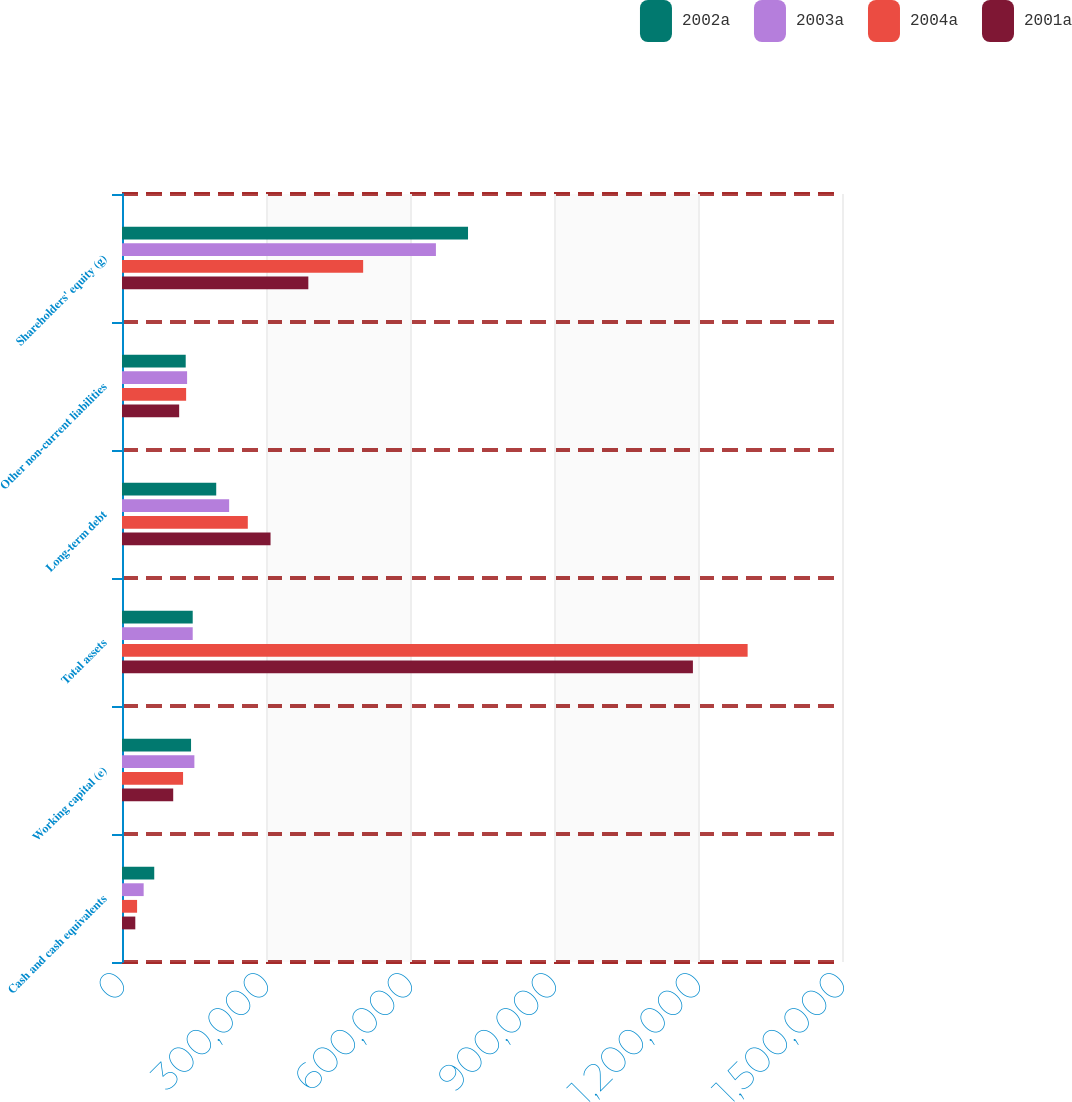Convert chart. <chart><loc_0><loc_0><loc_500><loc_500><stacked_bar_chart><ecel><fcel>Cash and cash equivalents<fcel>Working capital (e)<fcel>Total assets<fcel>Long-term debt<fcel>Other non-current liabilities<fcel>Shareholders' equity (g)<nl><fcel>2002a<fcel>67176<fcel>143848<fcel>147318<fcel>196290<fcel>132723<fcel>720886<nl><fcel>2003a<fcel>45116<fcel>150789<fcel>147318<fcel>223239<fcel>135613<fcel>653996<nl><fcel>2004a<fcel>31427<fcel>127214<fcel>1.30339e+06<fcel>262093<fcel>133600<fcel>502386<nl><fcel>2001a<fcel>27721<fcel>106689<fcel>1.18941e+06<fcel>309479<fcel>119109<fcel>388184<nl></chart> 